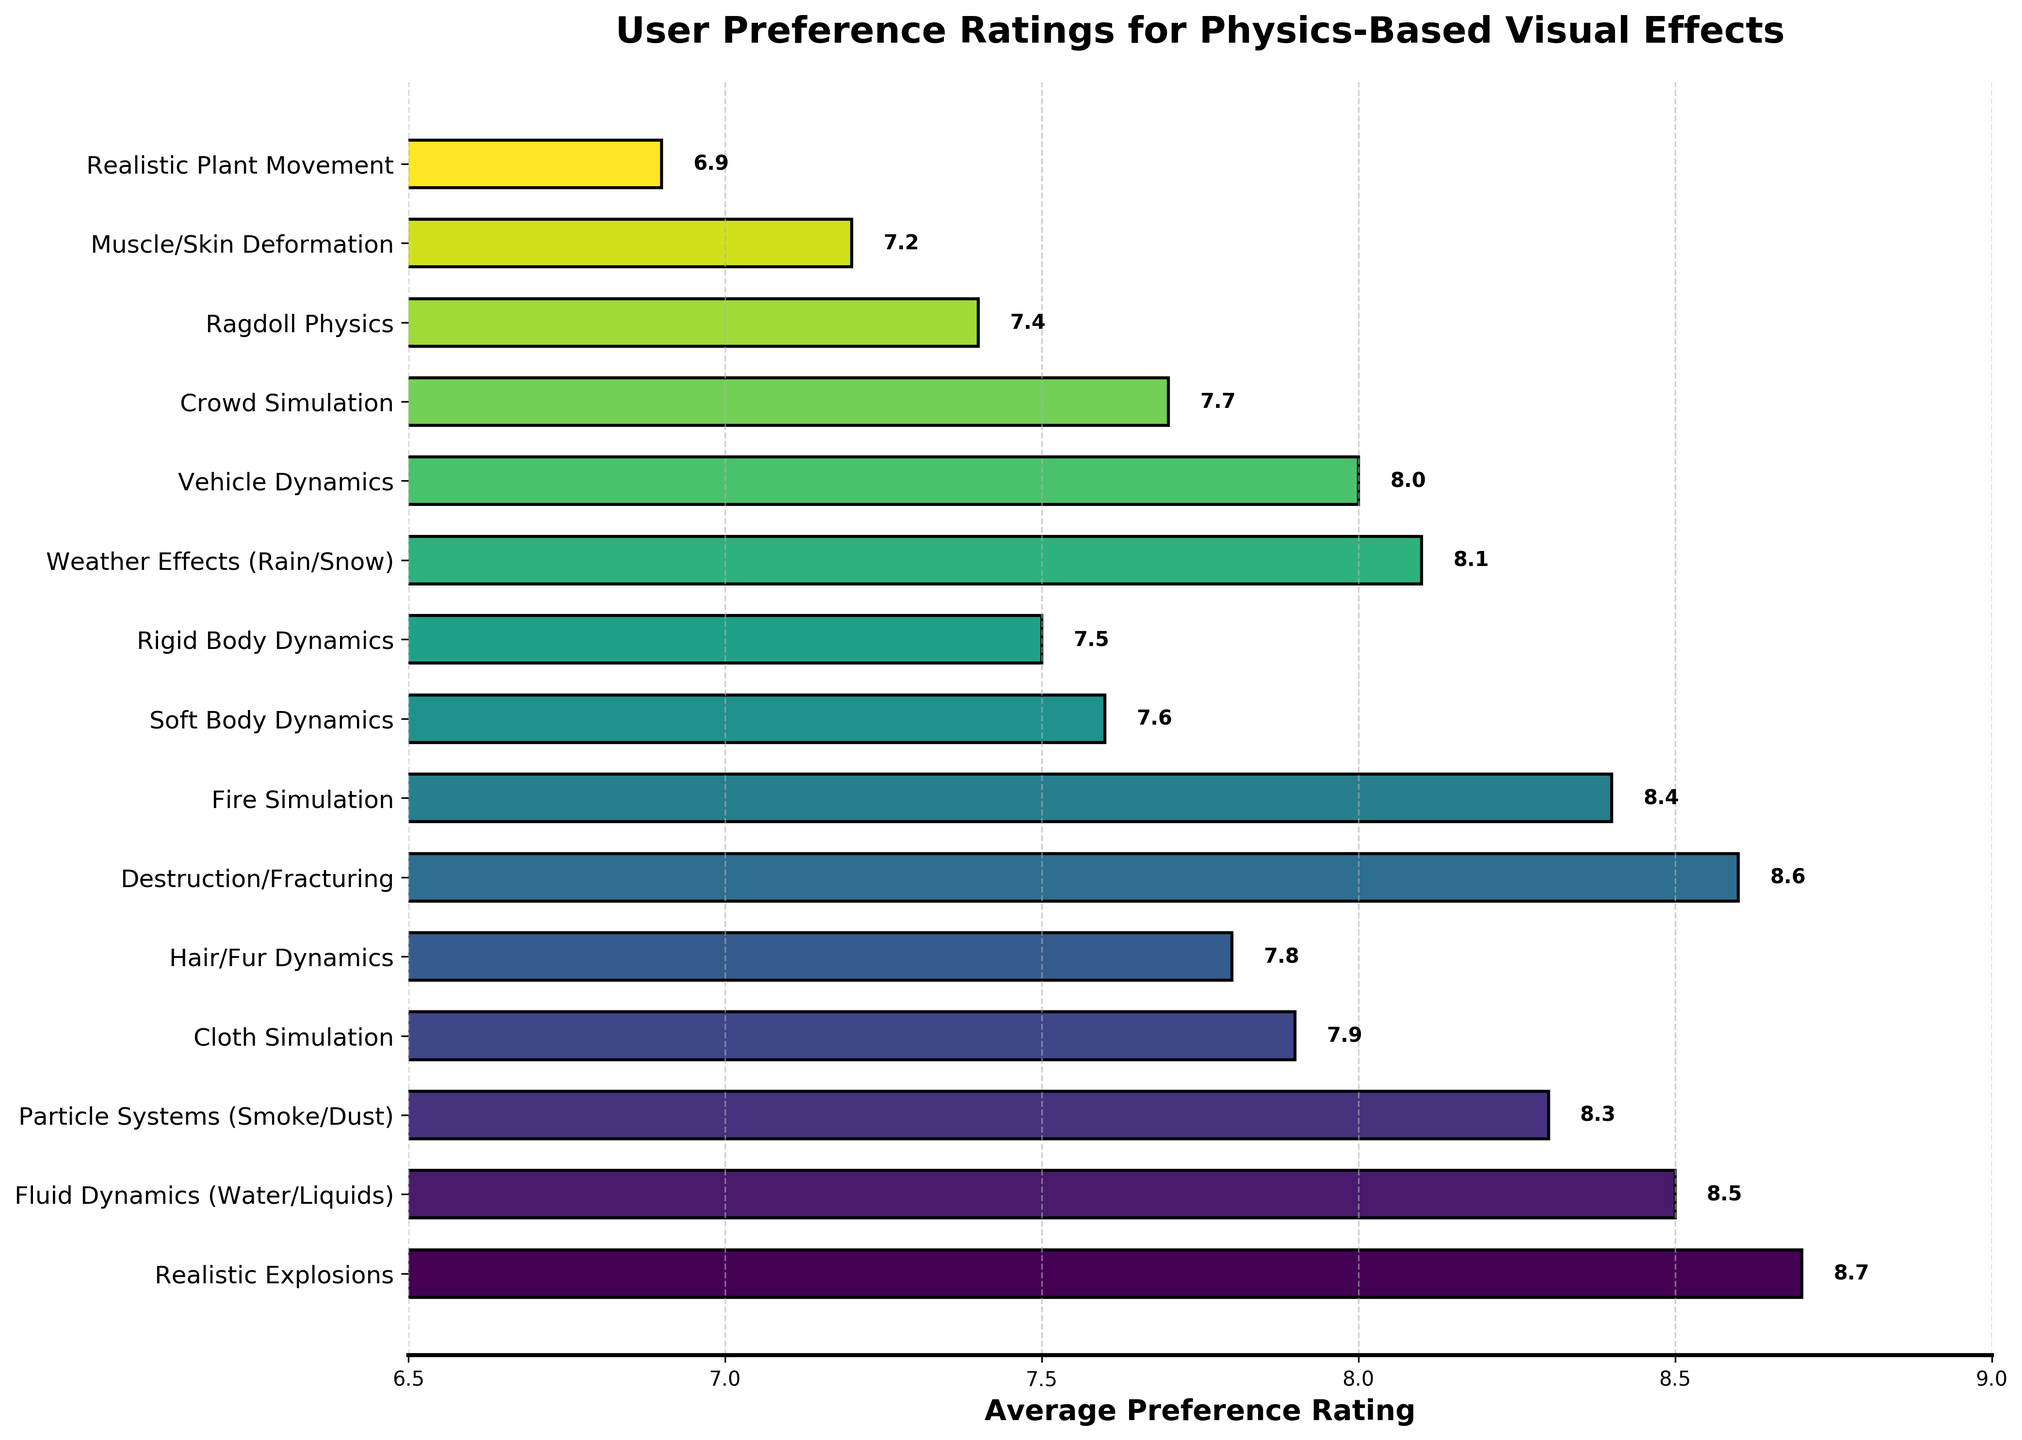What's the highest average preference rating in the chart? To determine the highest preference rating, we need to look for the maximum value in the 'Average Preference Rating' column in the vertical bars. 'Realistic Explosions' has the highest rating with a value of 8.7.
Answer: 8.7 What's the difference in average preference rating between 'Realistic Explosions' and 'Realistic Plant Movement'? Subtract the average preference rating of 'Realistic Plant Movement' from 'Realistic Explosions': 8.7 - 6.9 = 1.8.
Answer: 1.8 Which two effects have the closest average preference ratings, and what is the difference between them? The closest ratings are between 'Soft Body Dynamics' and 'Rigid Body Dynamics'. Their ratings are 7.6 and 7.5, respectively, with a difference of 7.6 - 7.5 = 0.1.
Answer: 'Soft Body Dynamics' and 'Rigid Body Dynamics', 0.1 List all effects whose average preference rating is higher than 8.0. By visual inspection of the bar lengths, the effects with ratings higher than 8.0 are: 'Realistic Explosions', 'Destruction/Fracturing', 'Fluid Dynamics (Water/Liquids)', 'Fire Simulation', 'Particle Systems (Smoke/Dust)', and 'Weather Effects (Rain/Snow)'.
Answer: 'Realistic Explosions', 'Destruction/Fracturing', 'Fluid Dynamics (Water/Liquids)', 'Fire Simulation', 'Particle Systems (Smoke/Dust)', 'Weather Effects (Rain/Snow)' What is the sum of the average preference ratings for 'Hair/Fur Dynamics', 'Vehicle Dynamics', and 'Crowd Simulation'? Add the average preference ratings for 'Hair/Fur Dynamics' (7.8), 'Vehicle Dynamics' (8.0), and 'Crowd Simulation' (7.7): 7.8 + 8.0 + 7.7 = 23.5.
Answer: 23.5 How many effects have an average preference rating of less than 7.5? Count the effects with bars having a preference rating less than 7.5. They are 'Ragdoll Physics' (7.4), 'Muscle/Skin Deformation' (7.2), and 'Realistic Plant Movement' (6.9). There are 3 such effects.
Answer: 3 Which effect has a higher average preference rating, 'Weather Effects (Rain/Snow)' or 'Vehicle Dynamics'? Compare the heights of the bars for 'Weather Effects (Rain/Snow)' (8.1) and 'Vehicle Dynamics' (8.0). 'Weather Effects (Rain/Snow)' has a higher rating.
Answer: 'Weather Effects (Rain/Snow)' What's the range of the average preference ratings represented in the chart? Calculate the range by subtracting the smallest value from the largest value in the average preference ratings. The highest is 8.7 (Realistic Explosions), and the lowest is 6.9 (Realistic Plant Movement): 8.7 - 6.9 = 1.8.
Answer: 1.8 